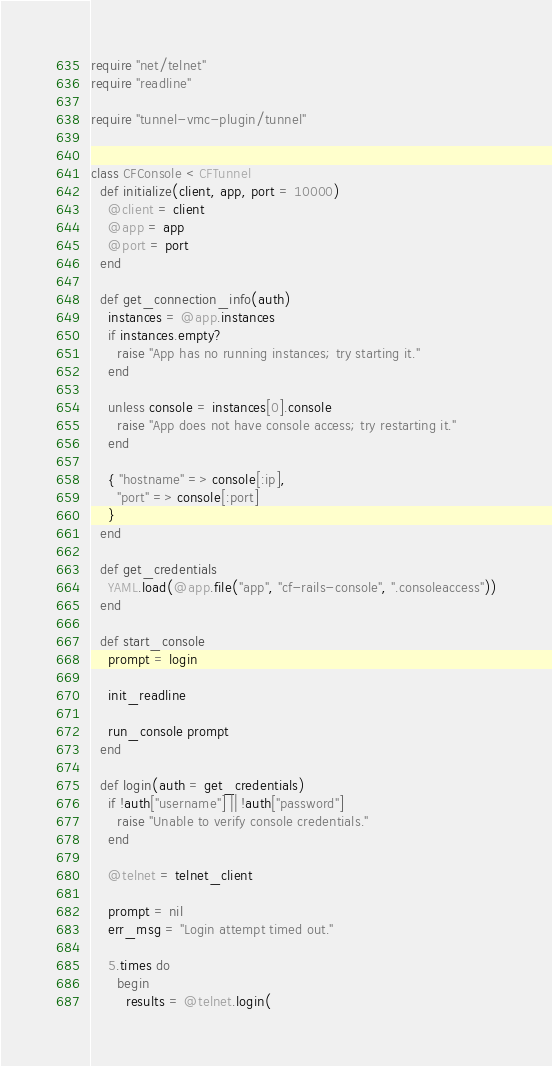<code> <loc_0><loc_0><loc_500><loc_500><_Ruby_>require "net/telnet"
require "readline"

require "tunnel-vmc-plugin/tunnel"


class CFConsole < CFTunnel
  def initialize(client, app, port = 10000)
    @client = client
    @app = app
    @port = port
  end

  def get_connection_info(auth)
    instances = @app.instances
    if instances.empty?
      raise "App has no running instances; try starting it."
    end

    unless console = instances[0].console
      raise "App does not have console access; try restarting it."
    end

    { "hostname" => console[:ip],
      "port" => console[:port]
    }
  end

  def get_credentials
    YAML.load(@app.file("app", "cf-rails-console", ".consoleaccess"))
  end

  def start_console
    prompt = login

    init_readline

    run_console prompt
  end

  def login(auth = get_credentials)
    if !auth["username"] || !auth["password"]
      raise "Unable to verify console credentials."
    end

    @telnet = telnet_client

    prompt = nil
    err_msg = "Login attempt timed out."

    5.times do
      begin
        results = @telnet.login(</code> 